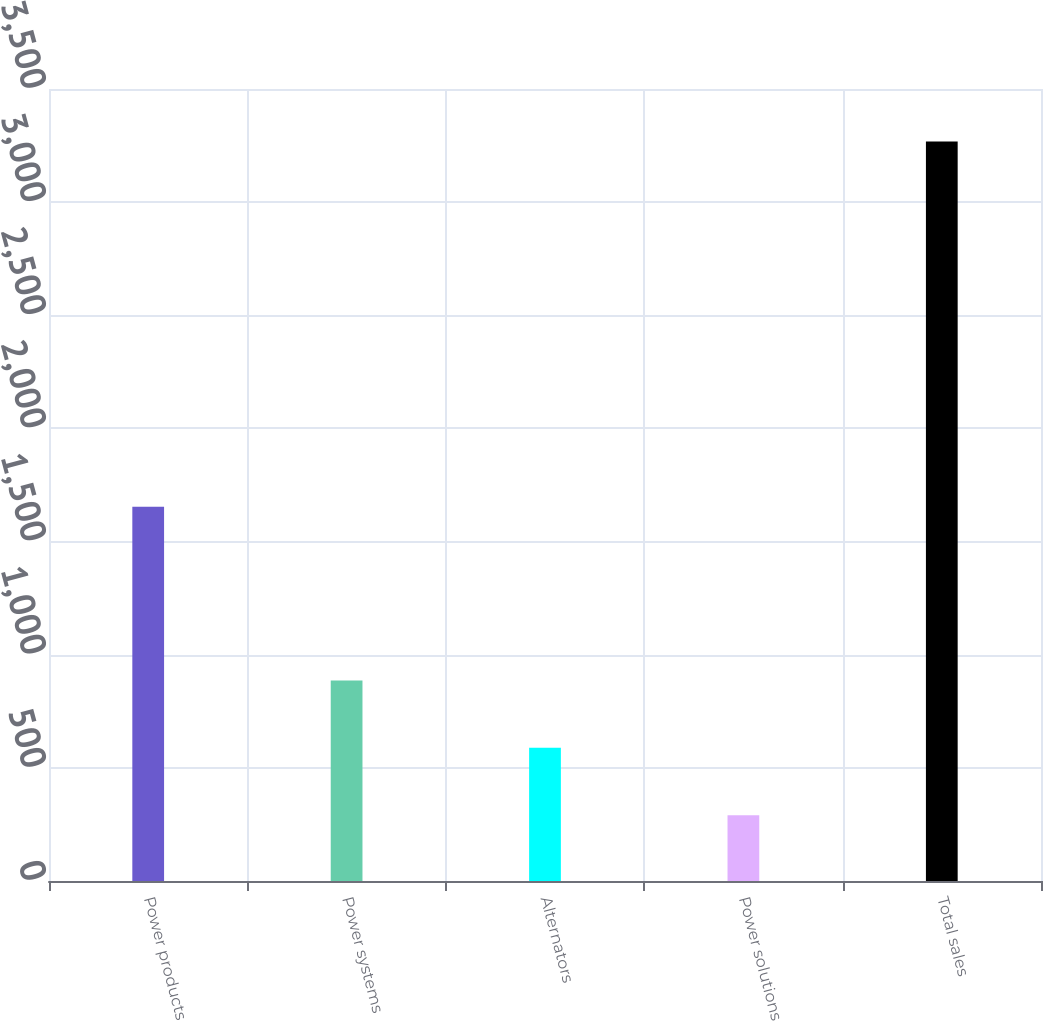Convert chart. <chart><loc_0><loc_0><loc_500><loc_500><bar_chart><fcel>Power products<fcel>Power systems<fcel>Alternators<fcel>Power solutions<fcel>Total sales<nl><fcel>1654<fcel>886.4<fcel>588.7<fcel>291<fcel>3268<nl></chart> 